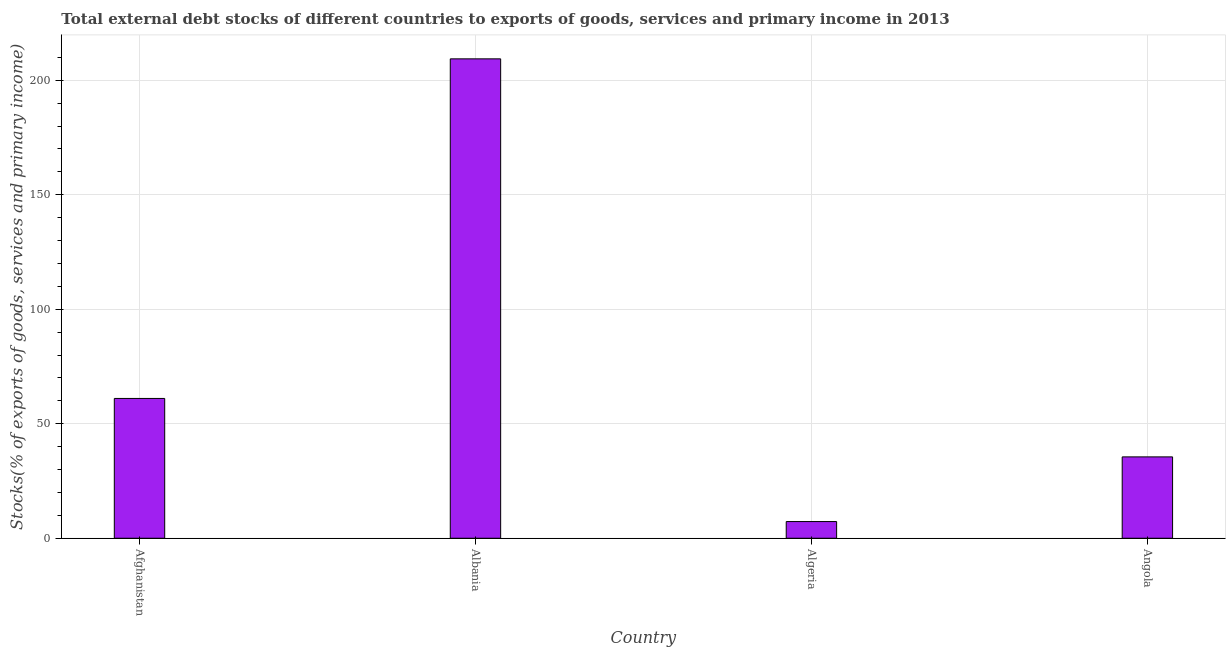Does the graph contain grids?
Make the answer very short. Yes. What is the title of the graph?
Ensure brevity in your answer.  Total external debt stocks of different countries to exports of goods, services and primary income in 2013. What is the label or title of the X-axis?
Keep it short and to the point. Country. What is the label or title of the Y-axis?
Your response must be concise. Stocks(% of exports of goods, services and primary income). What is the external debt stocks in Angola?
Your answer should be very brief. 35.53. Across all countries, what is the maximum external debt stocks?
Make the answer very short. 209.34. Across all countries, what is the minimum external debt stocks?
Offer a very short reply. 7.29. In which country was the external debt stocks maximum?
Provide a short and direct response. Albania. In which country was the external debt stocks minimum?
Make the answer very short. Algeria. What is the sum of the external debt stocks?
Your answer should be very brief. 313.2. What is the difference between the external debt stocks in Albania and Algeria?
Your response must be concise. 202.05. What is the average external debt stocks per country?
Your answer should be compact. 78.3. What is the median external debt stocks?
Your answer should be compact. 48.29. In how many countries, is the external debt stocks greater than 110 %?
Provide a short and direct response. 1. What is the ratio of the external debt stocks in Afghanistan to that in Algeria?
Your answer should be very brief. 8.38. Is the difference between the external debt stocks in Algeria and Angola greater than the difference between any two countries?
Your answer should be compact. No. What is the difference between the highest and the second highest external debt stocks?
Give a very brief answer. 148.3. What is the difference between the highest and the lowest external debt stocks?
Make the answer very short. 202.05. How many bars are there?
Keep it short and to the point. 4. Are all the bars in the graph horizontal?
Offer a very short reply. No. What is the difference between two consecutive major ticks on the Y-axis?
Your response must be concise. 50. What is the Stocks(% of exports of goods, services and primary income) of Afghanistan?
Your response must be concise. 61.04. What is the Stocks(% of exports of goods, services and primary income) of Albania?
Make the answer very short. 209.34. What is the Stocks(% of exports of goods, services and primary income) in Algeria?
Your answer should be compact. 7.29. What is the Stocks(% of exports of goods, services and primary income) of Angola?
Your answer should be compact. 35.53. What is the difference between the Stocks(% of exports of goods, services and primary income) in Afghanistan and Albania?
Ensure brevity in your answer.  -148.3. What is the difference between the Stocks(% of exports of goods, services and primary income) in Afghanistan and Algeria?
Your response must be concise. 53.76. What is the difference between the Stocks(% of exports of goods, services and primary income) in Afghanistan and Angola?
Your answer should be very brief. 25.52. What is the difference between the Stocks(% of exports of goods, services and primary income) in Albania and Algeria?
Make the answer very short. 202.05. What is the difference between the Stocks(% of exports of goods, services and primary income) in Albania and Angola?
Provide a short and direct response. 173.81. What is the difference between the Stocks(% of exports of goods, services and primary income) in Algeria and Angola?
Give a very brief answer. -28.24. What is the ratio of the Stocks(% of exports of goods, services and primary income) in Afghanistan to that in Albania?
Offer a very short reply. 0.29. What is the ratio of the Stocks(% of exports of goods, services and primary income) in Afghanistan to that in Algeria?
Your answer should be compact. 8.38. What is the ratio of the Stocks(% of exports of goods, services and primary income) in Afghanistan to that in Angola?
Provide a short and direct response. 1.72. What is the ratio of the Stocks(% of exports of goods, services and primary income) in Albania to that in Algeria?
Provide a succinct answer. 28.73. What is the ratio of the Stocks(% of exports of goods, services and primary income) in Albania to that in Angola?
Your answer should be compact. 5.89. What is the ratio of the Stocks(% of exports of goods, services and primary income) in Algeria to that in Angola?
Your response must be concise. 0.2. 